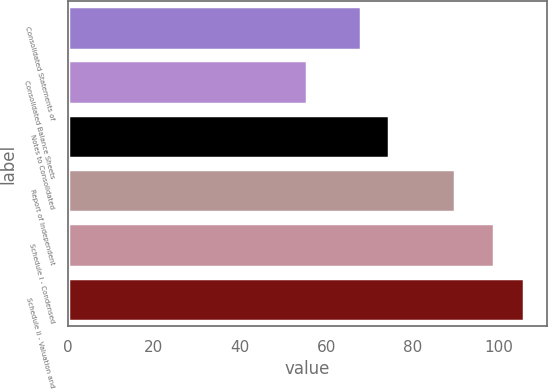<chart> <loc_0><loc_0><loc_500><loc_500><bar_chart><fcel>Consolidated Statements of<fcel>Consolidated Balance Sheets<fcel>Notes to Consolidated<fcel>Report of Independent<fcel>Schedule I - Condensed<fcel>Schedule II - Valuation and<nl><fcel>68.2<fcel>55.6<fcel>74.5<fcel>90<fcel>99<fcel>106<nl></chart> 